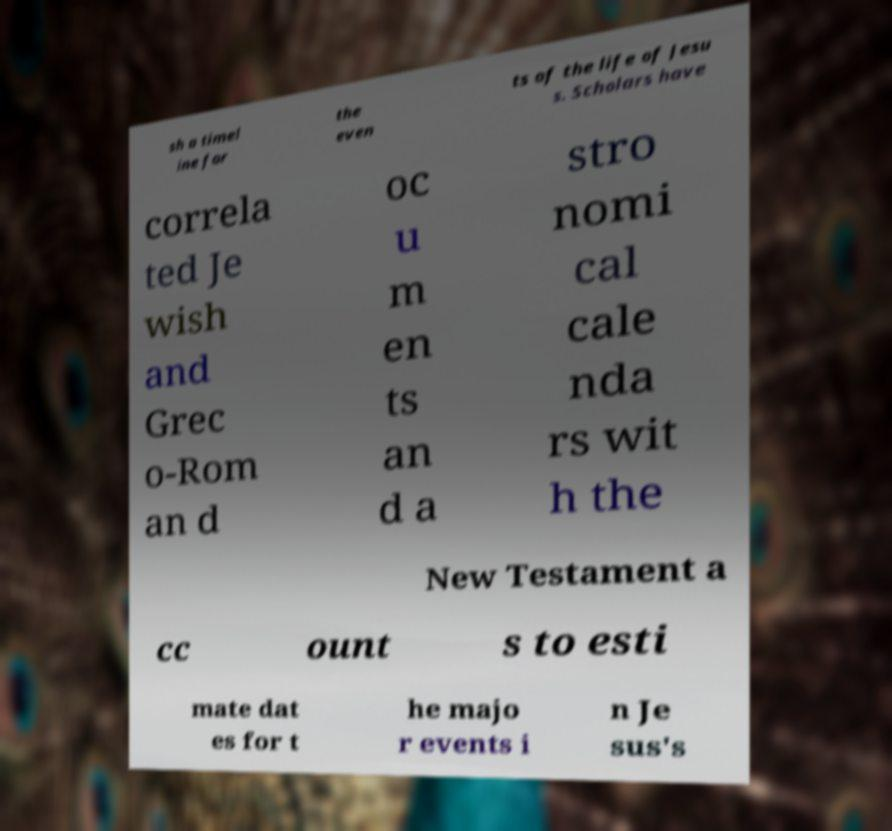Could you assist in decoding the text presented in this image and type it out clearly? sh a timel ine for the even ts of the life of Jesu s. Scholars have correla ted Je wish and Grec o-Rom an d oc u m en ts an d a stro nomi cal cale nda rs wit h the New Testament a cc ount s to esti mate dat es for t he majo r events i n Je sus's 